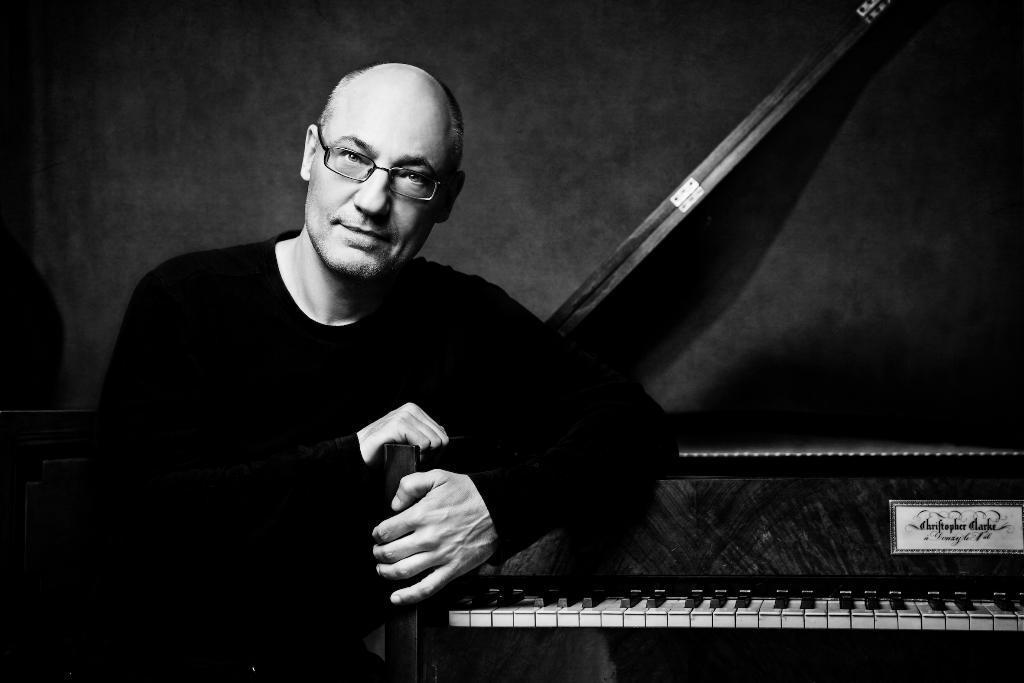Could you give a brief overview of what you see in this image? In this picture there is a person who is holding a musical instrument and sitting on the chair. 